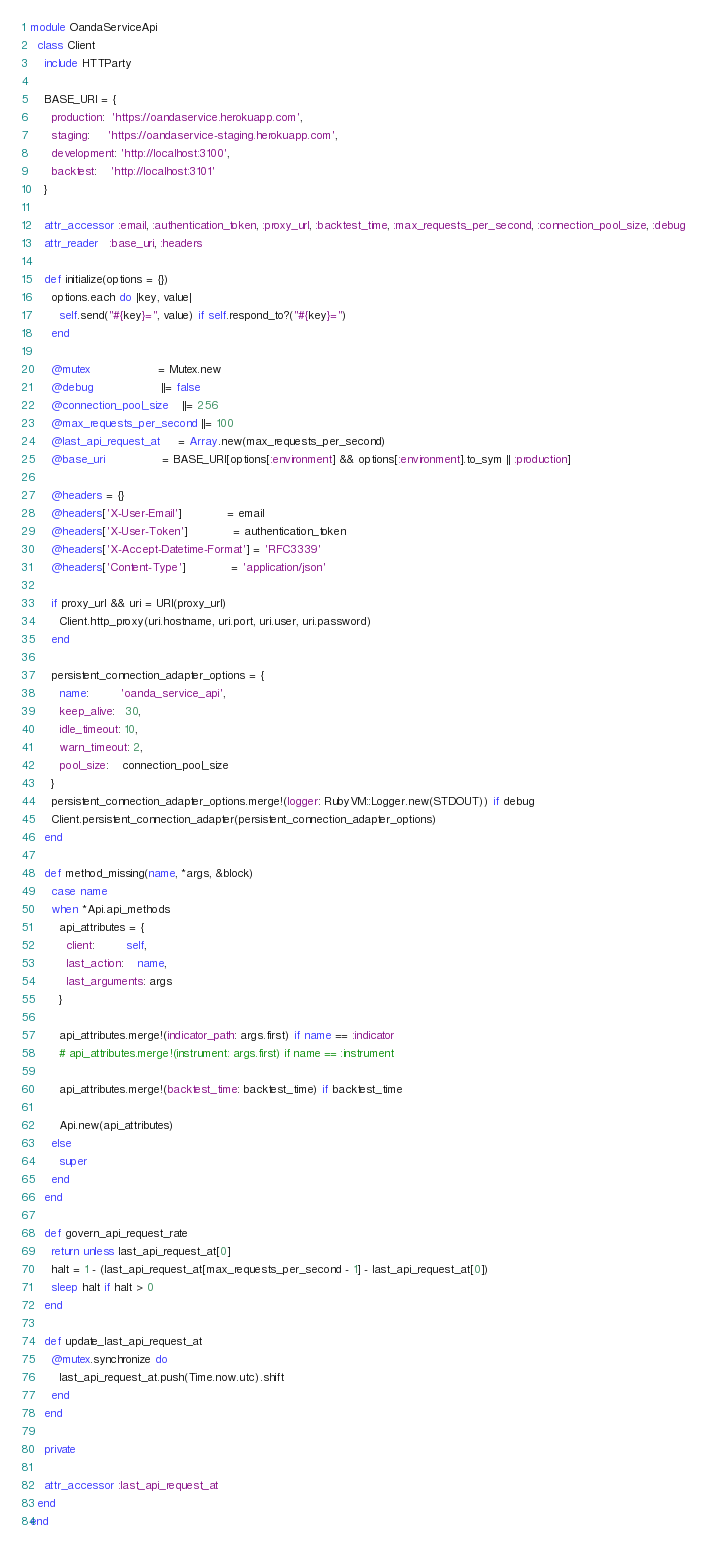<code> <loc_0><loc_0><loc_500><loc_500><_Ruby_>module OandaServiceApi
  class Client
    include HTTParty

    BASE_URI = {
      production:  'https://oandaservice.herokuapp.com',
      staging:     'https://oandaservice-staging.herokuapp.com',
      development: 'http://localhost:3100',
      backtest:    'http://localhost:3101'
    }

    attr_accessor :email, :authentication_token, :proxy_url, :backtest_time, :max_requests_per_second, :connection_pool_size, :debug
    attr_reader   :base_uri, :headers

    def initialize(options = {})
      options.each do |key, value|
        self.send("#{key}=", value) if self.respond_to?("#{key}=")
      end

      @mutex                   = Mutex.new
      @debug                   ||= false
      @connection_pool_size    ||= 256
      @max_requests_per_second ||= 100
      @last_api_request_at     = Array.new(max_requests_per_second)
      @base_uri                = BASE_URI[options[:environment] && options[:environment].to_sym || :production]

      @headers = {}
      @headers['X-User-Email']             = email
      @headers['X-User-Token']             = authentication_token
      @headers['X-Accept-Datetime-Format'] = 'RFC3339'
      @headers['Content-Type']             = 'application/json'

      if proxy_url && uri = URI(proxy_url)
        Client.http_proxy(uri.hostname, uri.port, uri.user, uri.password)
      end

      persistent_connection_adapter_options = {
        name:         'oanda_service_api',
        keep_alive:   30,
        idle_timeout: 10,
        warn_timeout: 2,
        pool_size:    connection_pool_size
      }
      persistent_connection_adapter_options.merge!(logger: RubyVM::Logger.new(STDOUT)) if debug
      Client.persistent_connection_adapter(persistent_connection_adapter_options)
    end

    def method_missing(name, *args, &block)
      case name
      when *Api.api_methods
        api_attributes = {
          client:         self,
          last_action:    name,
          last_arguments: args
        }

        api_attributes.merge!(indicator_path: args.first) if name == :indicator
        # api_attributes.merge!(instrument: args.first) if name == :instrument

        api_attributes.merge!(backtest_time: backtest_time) if backtest_time

        Api.new(api_attributes)
      else
        super
      end
    end

    def govern_api_request_rate
      return unless last_api_request_at[0]
      halt = 1 - (last_api_request_at[max_requests_per_second - 1] - last_api_request_at[0])
      sleep halt if halt > 0
    end

    def update_last_api_request_at
      @mutex.synchronize do
        last_api_request_at.push(Time.now.utc).shift
      end
    end

    private

    attr_accessor :last_api_request_at
  end
end
</code> 